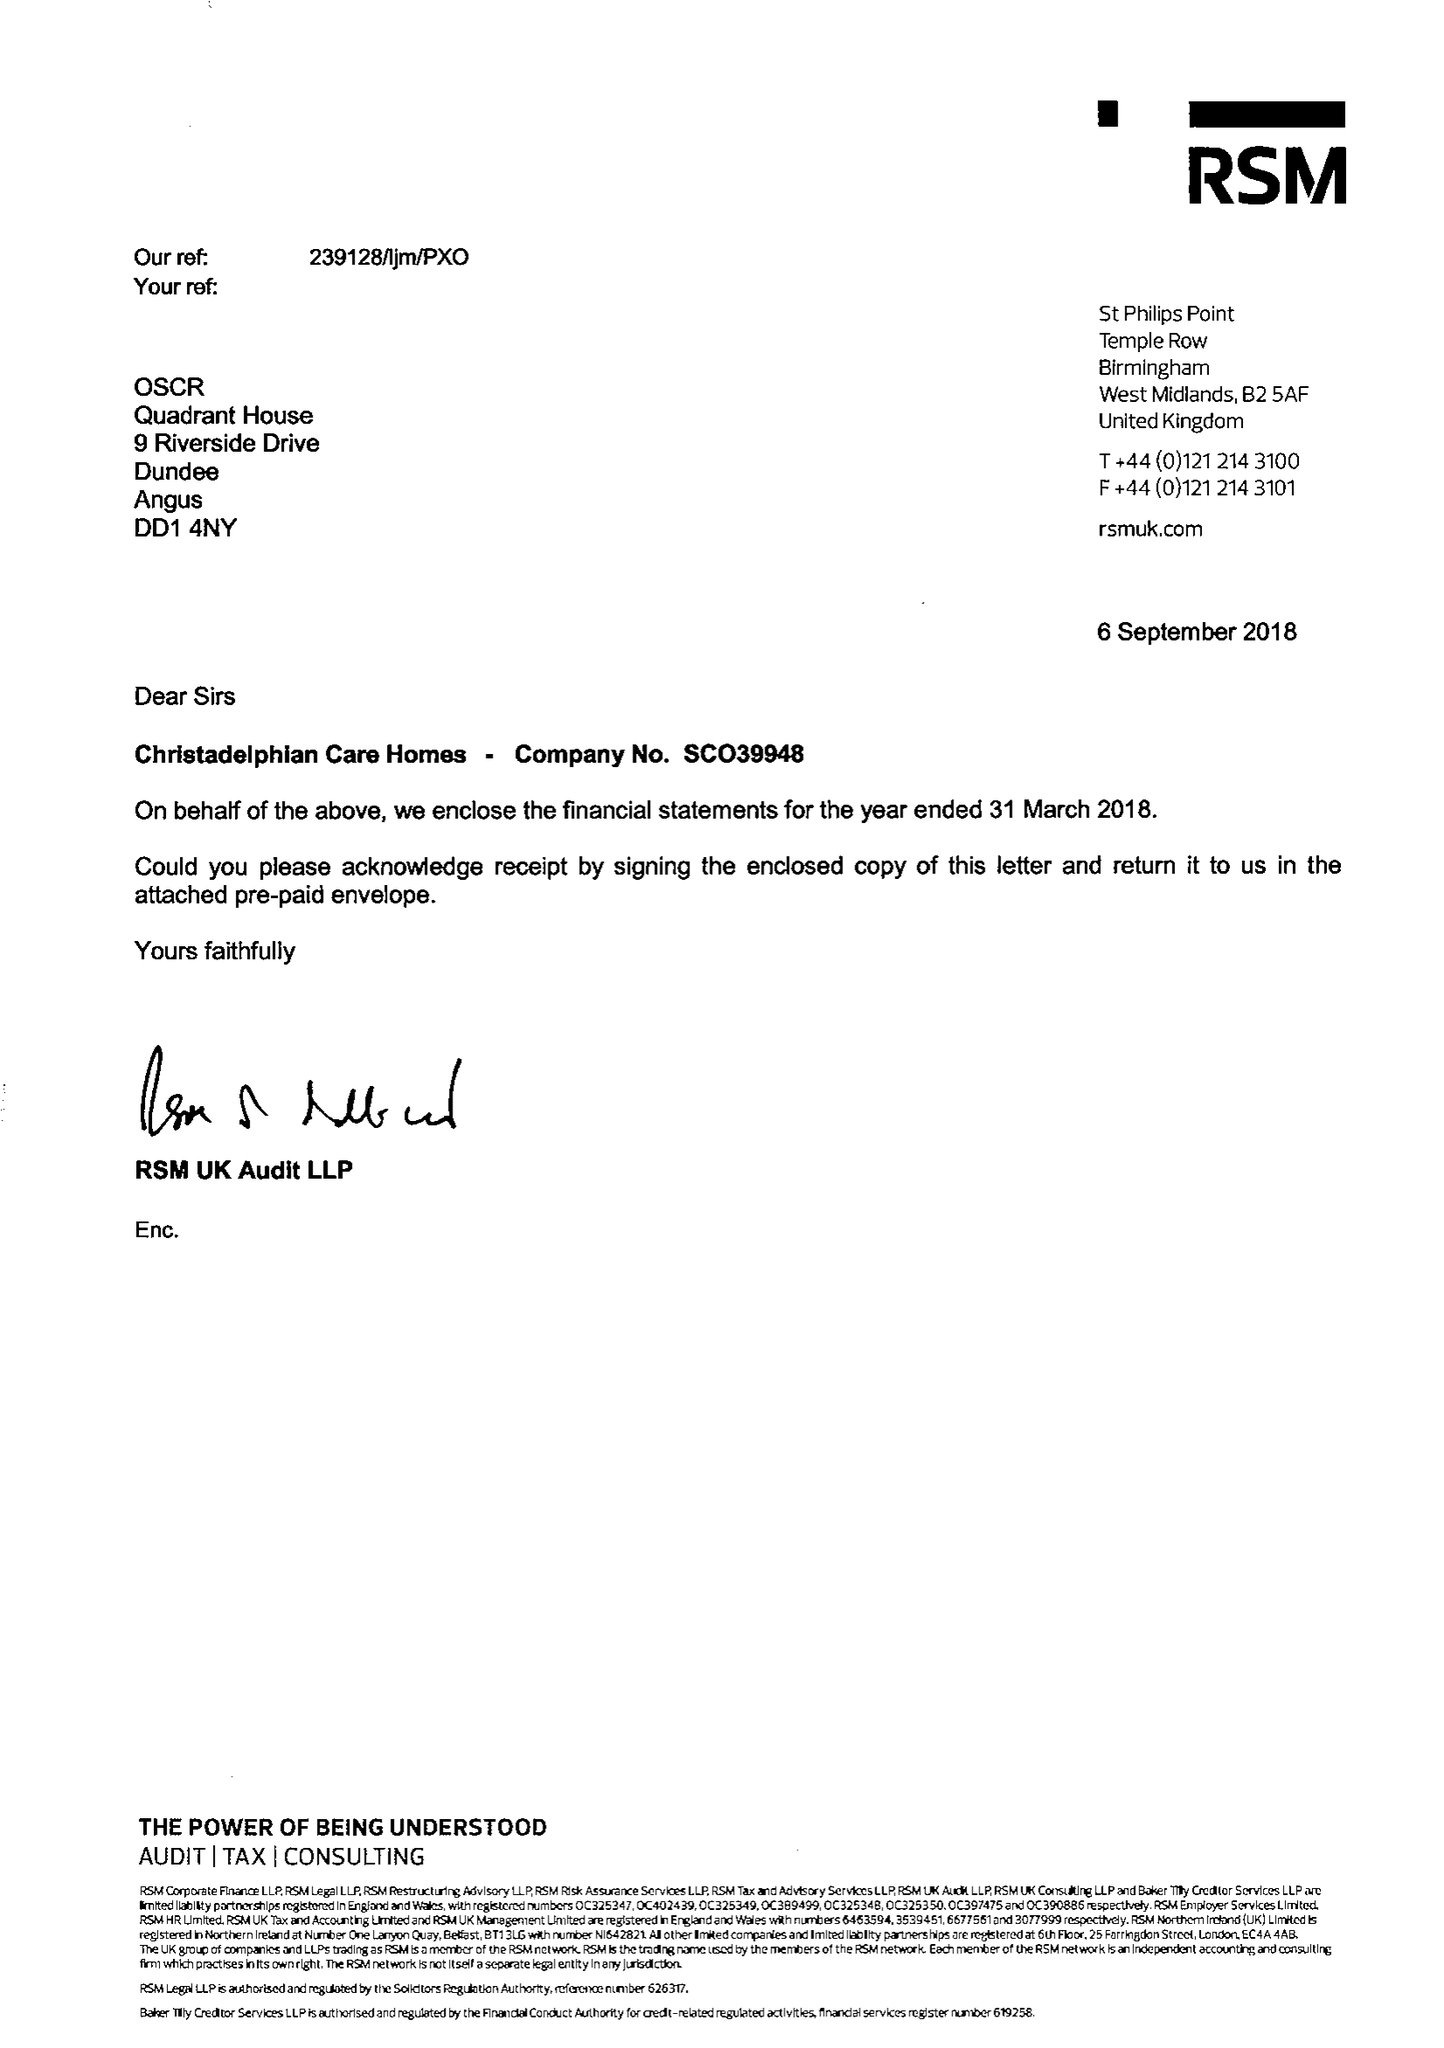What is the value for the address__postcode?
Answer the question using a single word or phrase. B27 6AD 